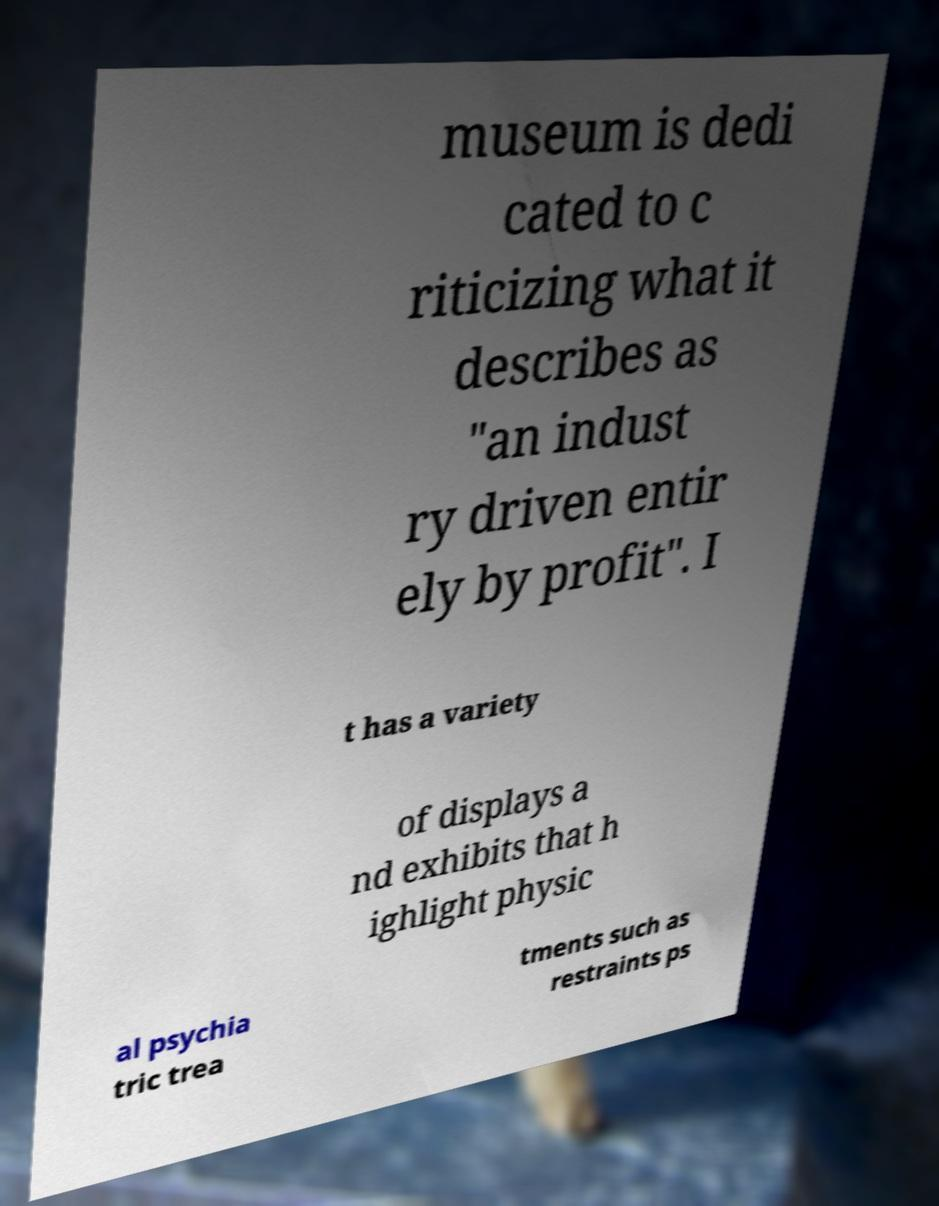What messages or text are displayed in this image? I need them in a readable, typed format. museum is dedi cated to c riticizing what it describes as "an indust ry driven entir ely by profit". I t has a variety of displays a nd exhibits that h ighlight physic al psychia tric trea tments such as restraints ps 